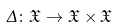Convert formula to latex. <formula><loc_0><loc_0><loc_500><loc_500>\Delta \colon { \mathfrak { X } } \to { \mathfrak { X } } \times { \mathfrak { X } }</formula> 